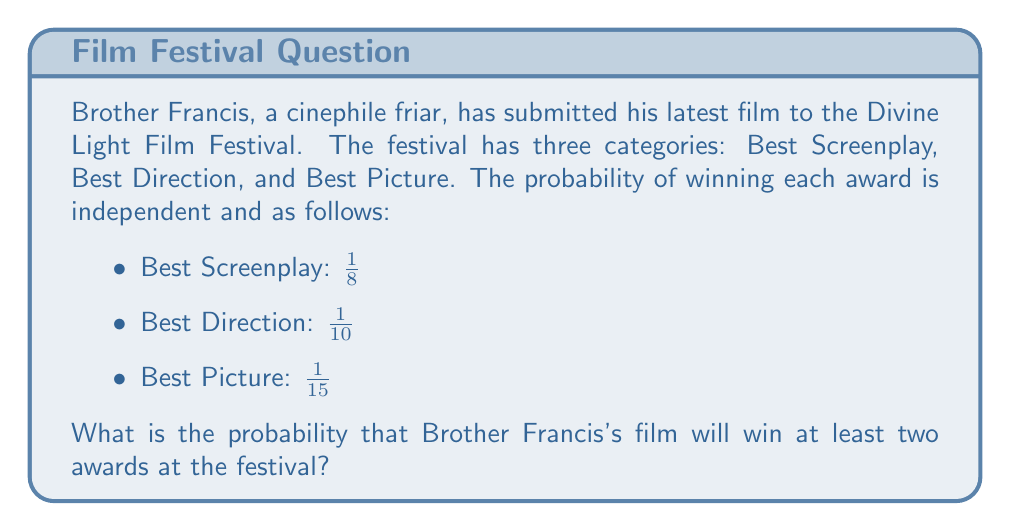Can you solve this math problem? To solve this problem, we'll use the concept of probability for multiple events. We need to find the probability of winning at least two awards, which is equal to the probability of winning exactly two awards plus the probability of winning all three awards.

Let's break it down step by step:

1) First, let's calculate the probability of winning each award:
   $P(Screenplay) = \frac{1}{8}$
   $P(Direction) = \frac{1}{10}$
   $P(Picture) = \frac{1}{15}$

2) The probability of not winning each award:
   $P(Not\,Screenplay) = 1 - \frac{1}{8} = \frac{7}{8}$
   $P(Not\,Direction) = 1 - \frac{1}{10} = \frac{9}{10}$
   $P(Not\,Picture) = 1 - \frac{1}{15} = \frac{14}{15}$

3) Now, let's calculate the probability of winning exactly two awards:
   
   a) Screenplay and Direction, but not Picture:
      $\frac{1}{8} \cdot \frac{1}{10} \cdot \frac{14}{15} = \frac{7}{600}$
   
   b) Screenplay and Picture, but not Direction:
      $\frac{1}{8} \cdot \frac{9}{10} \cdot \frac{1}{15} = \frac{3}{400}$
   
   c) Direction and Picture, but not Screenplay:
      $\frac{7}{8} \cdot \frac{1}{10} \cdot \frac{1}{15} = \frac{7}{1200}$

4) The probability of winning all three awards:
   $\frac{1}{8} \cdot \frac{1}{10} \cdot \frac{1}{15} = \frac{1}{1200}$

5) Now, we sum all these probabilities:
   $P(at\,least\,two) = \frac{7}{600} + \frac{3}{400} + \frac{7}{1200} + \frac{1}{1200}$
   
   $= \frac{14}{1200} + \frac{9}{1200} + \frac{7}{1200} + \frac{1}{1200}$
   
   $= \frac{31}{1200}$

Therefore, the probability of Brother Francis's film winning at least two awards is $\frac{31}{1200}$.
Answer: $\frac{31}{1200}$ or approximately $0.0258$ or $2.58\%$ 